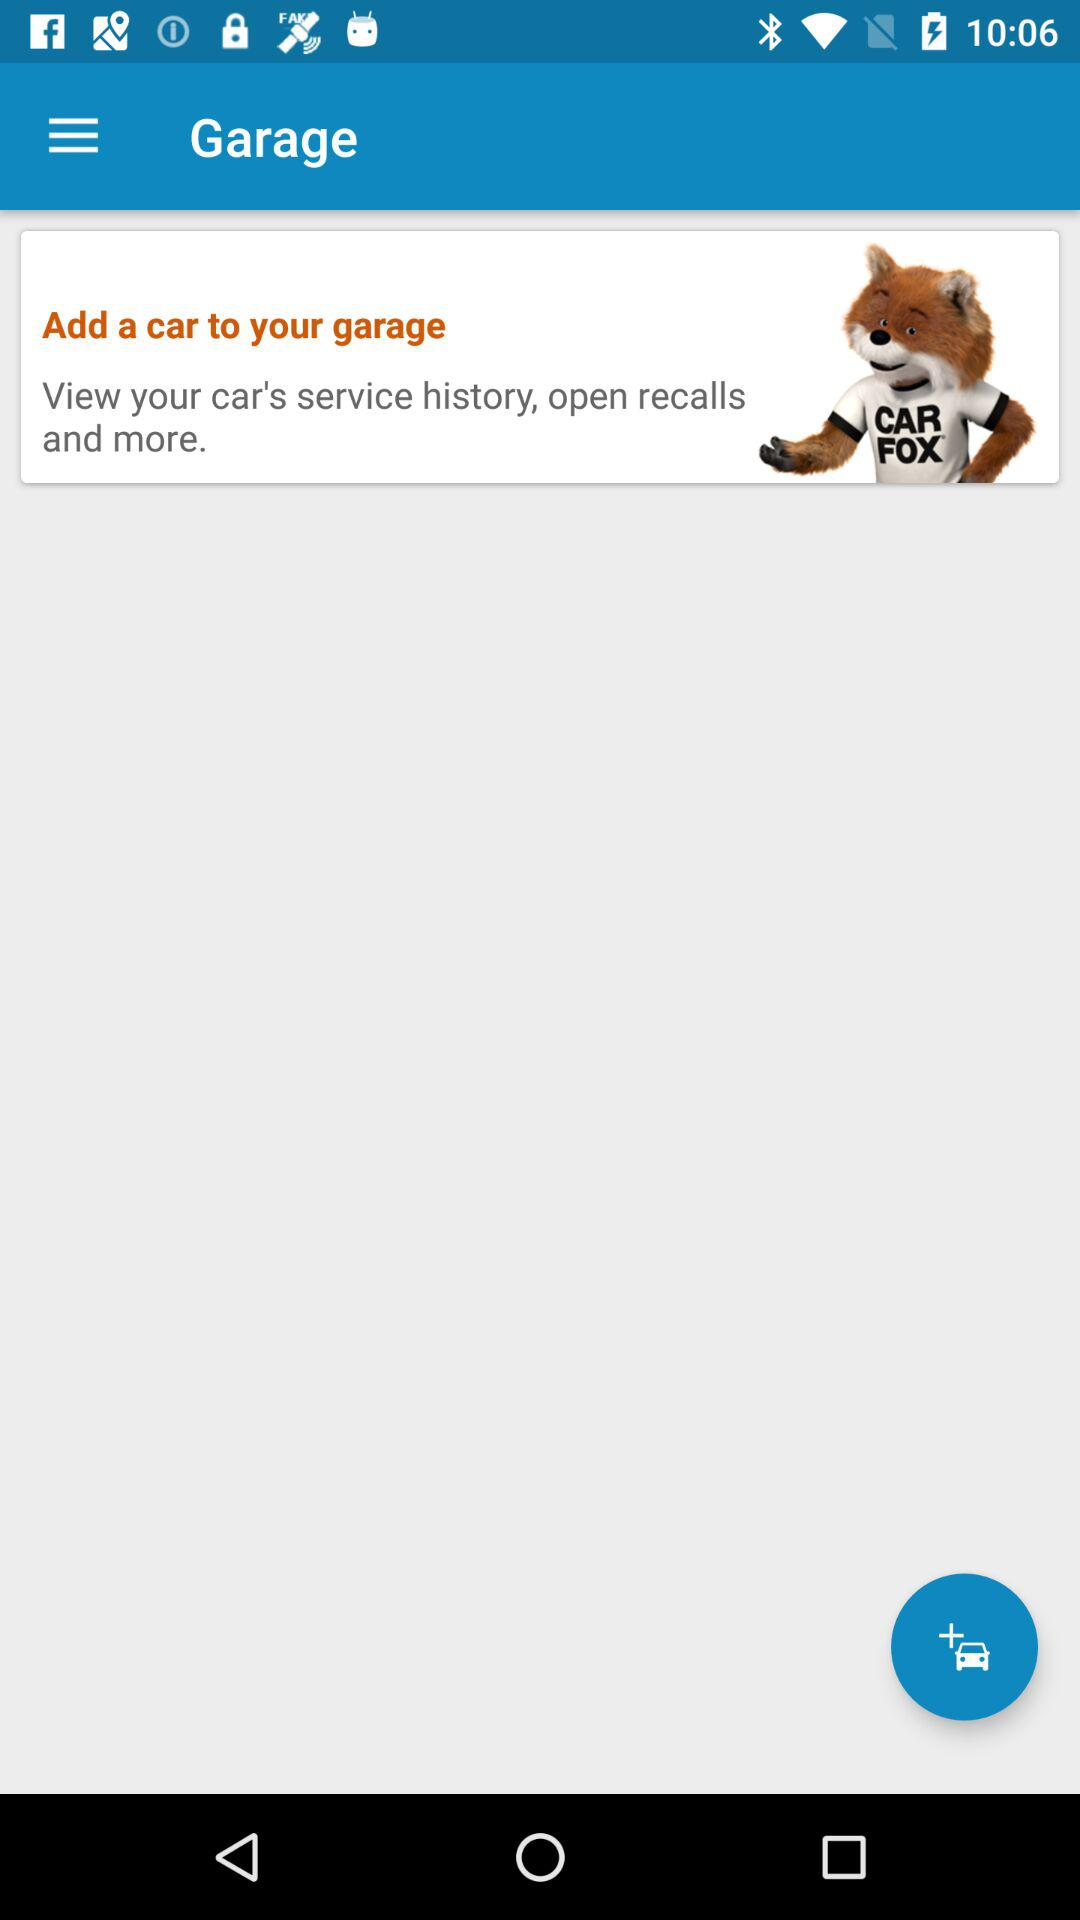What is the application name? The application name is "Garage". 